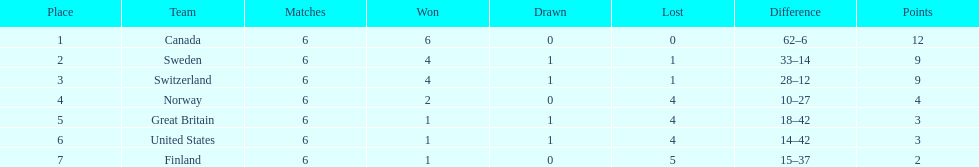How many teams won only 1 match? 3. 